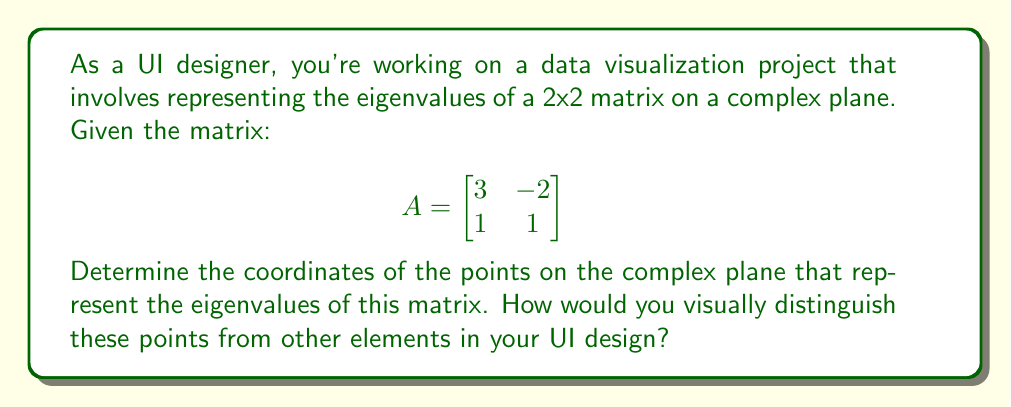Could you help me with this problem? To find the eigenvalues and visualize them on the complex plane, we'll follow these steps:

1) Calculate the characteristic polynomial:
   $$det(A - \lambda I) = \begin{vmatrix}
   3-\lambda & -2 \\
   1 & 1-\lambda
   \end{vmatrix} = (3-\lambda)(1-\lambda) - (-2)(1) = \lambda^2 - 4\lambda + 5$$

2) Solve the characteristic equation:
   $$\lambda^2 - 4\lambda + 5 = 0$$

3) Use the quadratic formula: $\lambda = \frac{-b \pm \sqrt{b^2 - 4ac}}{2a}$
   $$\lambda = \frac{4 \pm \sqrt{16 - 20}}{2} = \frac{4 \pm \sqrt{-4}}{2} = \frac{4 \pm 2i}{2} = 2 \pm i$$

4) The eigenvalues are:
   $$\lambda_1 = 2 + i \text{ and } \lambda_2 = 2 - i$$

5) On the complex plane:
   - $\lambda_1$ is at coordinate (2, 1)
   - $\lambda_2$ is at coordinate (2, -1)

[asy]
import graph;
size(200);
xaxis("Re", -1, 4, Arrow);
yaxis("Im", -2, 2, Arrow);
dot((2,1), red);
dot((2,-1), red);
label("$\lambda_1$", (2,1), NE);
label("$\lambda_2$", (2,-1), SE);
[/asy]

To visually distinguish these points in a UI design:
1) Use a distinct color (e.g., red) for the eigenvalue points.
2) Implement hover effects to display the exact values when a user interacts with the points.
3) Use a slightly larger size for these points compared to other elements.
4) Add subtle animations or glow effects to draw attention to these critical points.
Answer: $\lambda_1 = 2 + i$, $\lambda_2 = 2 - i$; Use distinct color, size, and interactive effects. 